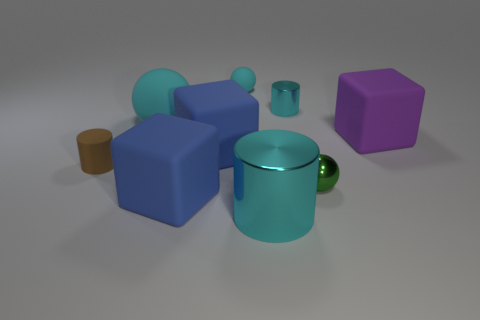Add 1 gray cylinders. How many objects exist? 10 Subtract all small metal balls. How many balls are left? 2 Subtract all cyan cylinders. Subtract all red balls. How many cylinders are left? 1 Subtract all yellow spheres. How many blue blocks are left? 2 Subtract all big blue matte objects. Subtract all big purple objects. How many objects are left? 6 Add 7 small cyan shiny cylinders. How many small cyan shiny cylinders are left? 8 Add 7 large balls. How many large balls exist? 8 Subtract all purple cubes. How many cubes are left? 2 Subtract 1 green balls. How many objects are left? 8 Subtract all spheres. How many objects are left? 6 